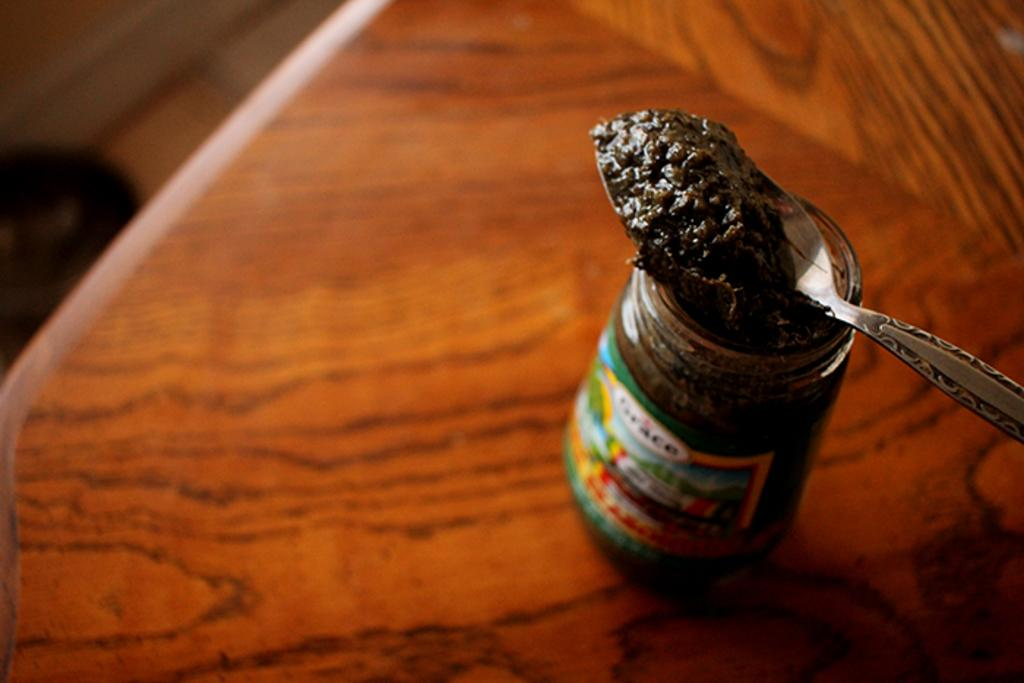What type of table is in the image? There is a wooden table in the image. What is on the table? There is a jar with food on the table. Can you describe the jar? The jar has a sticker on it. What is positioned above the jar? There is a spoon above the jar. What territory does the father claim in the image? There is no reference to a father or territory in the image. 